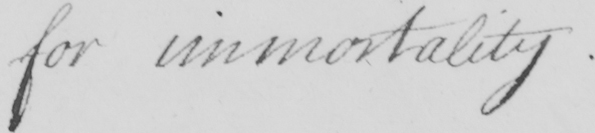Can you read and transcribe this handwriting? for immortality . 